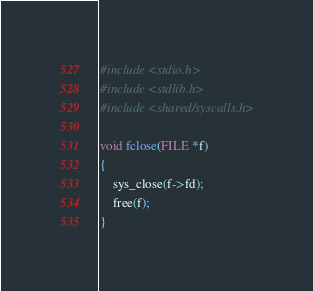Convert code to text. <code><loc_0><loc_0><loc_500><loc_500><_C_>#include <stdio.h>
#include <stdlib.h>
#include <shared/syscalls.h>

void fclose(FILE *f)
{
    sys_close(f->fd);
    free(f);
}
</code> 